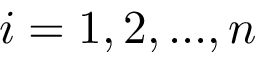<formula> <loc_0><loc_0><loc_500><loc_500>i = 1 , 2 , \dots , n</formula> 